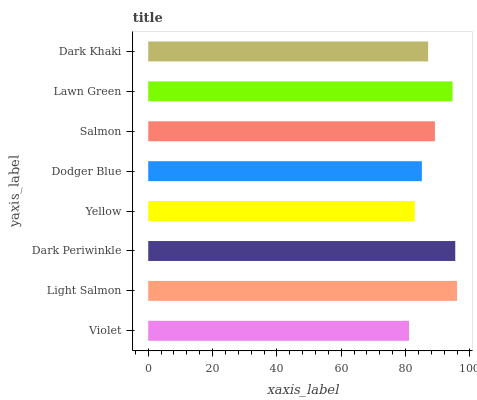Is Violet the minimum?
Answer yes or no. Yes. Is Light Salmon the maximum?
Answer yes or no. Yes. Is Dark Periwinkle the minimum?
Answer yes or no. No. Is Dark Periwinkle the maximum?
Answer yes or no. No. Is Light Salmon greater than Dark Periwinkle?
Answer yes or no. Yes. Is Dark Periwinkle less than Light Salmon?
Answer yes or no. Yes. Is Dark Periwinkle greater than Light Salmon?
Answer yes or no. No. Is Light Salmon less than Dark Periwinkle?
Answer yes or no. No. Is Salmon the high median?
Answer yes or no. Yes. Is Dark Khaki the low median?
Answer yes or no. Yes. Is Dodger Blue the high median?
Answer yes or no. No. Is Light Salmon the low median?
Answer yes or no. No. 